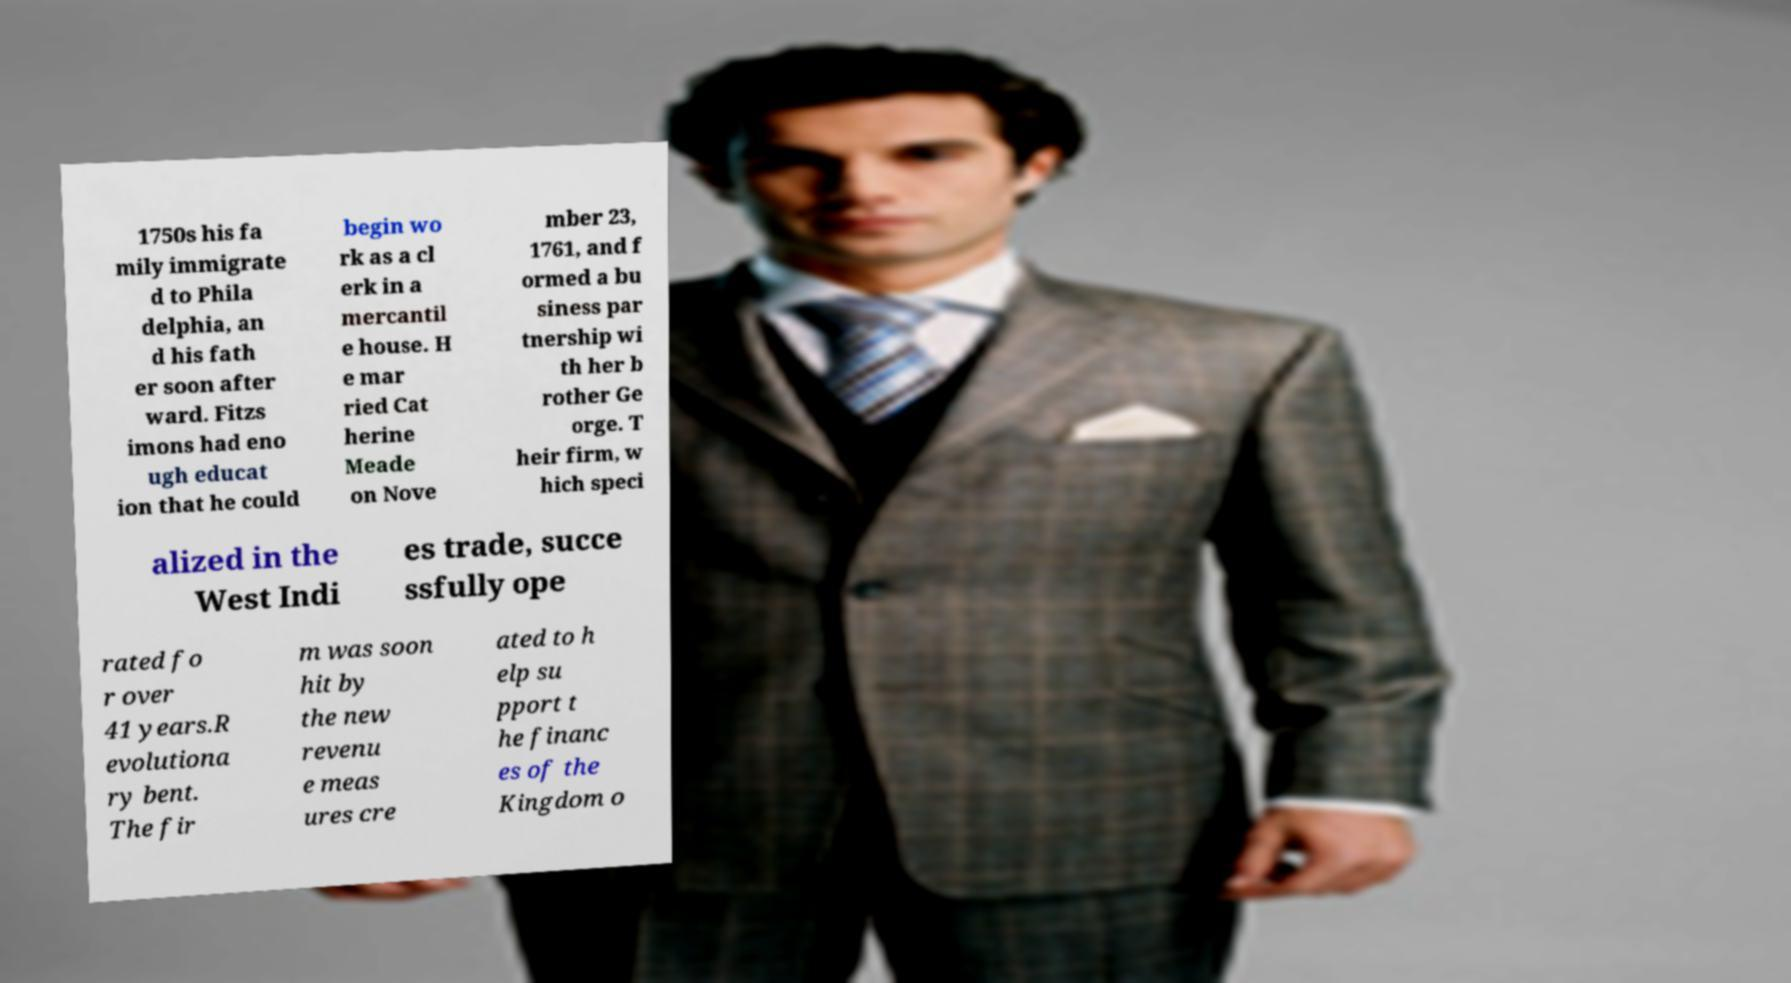For documentation purposes, I need the text within this image transcribed. Could you provide that? 1750s his fa mily immigrate d to Phila delphia, an d his fath er soon after ward. Fitzs imons had eno ugh educat ion that he could begin wo rk as a cl erk in a mercantil e house. H e mar ried Cat herine Meade on Nove mber 23, 1761, and f ormed a bu siness par tnership wi th her b rother Ge orge. T heir firm, w hich speci alized in the West Indi es trade, succe ssfully ope rated fo r over 41 years.R evolutiona ry bent. The fir m was soon hit by the new revenu e meas ures cre ated to h elp su pport t he financ es of the Kingdom o 